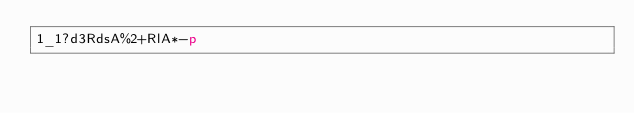<code> <loc_0><loc_0><loc_500><loc_500><_dc_>1_1?d3RdsA%2+RlA*-p</code> 